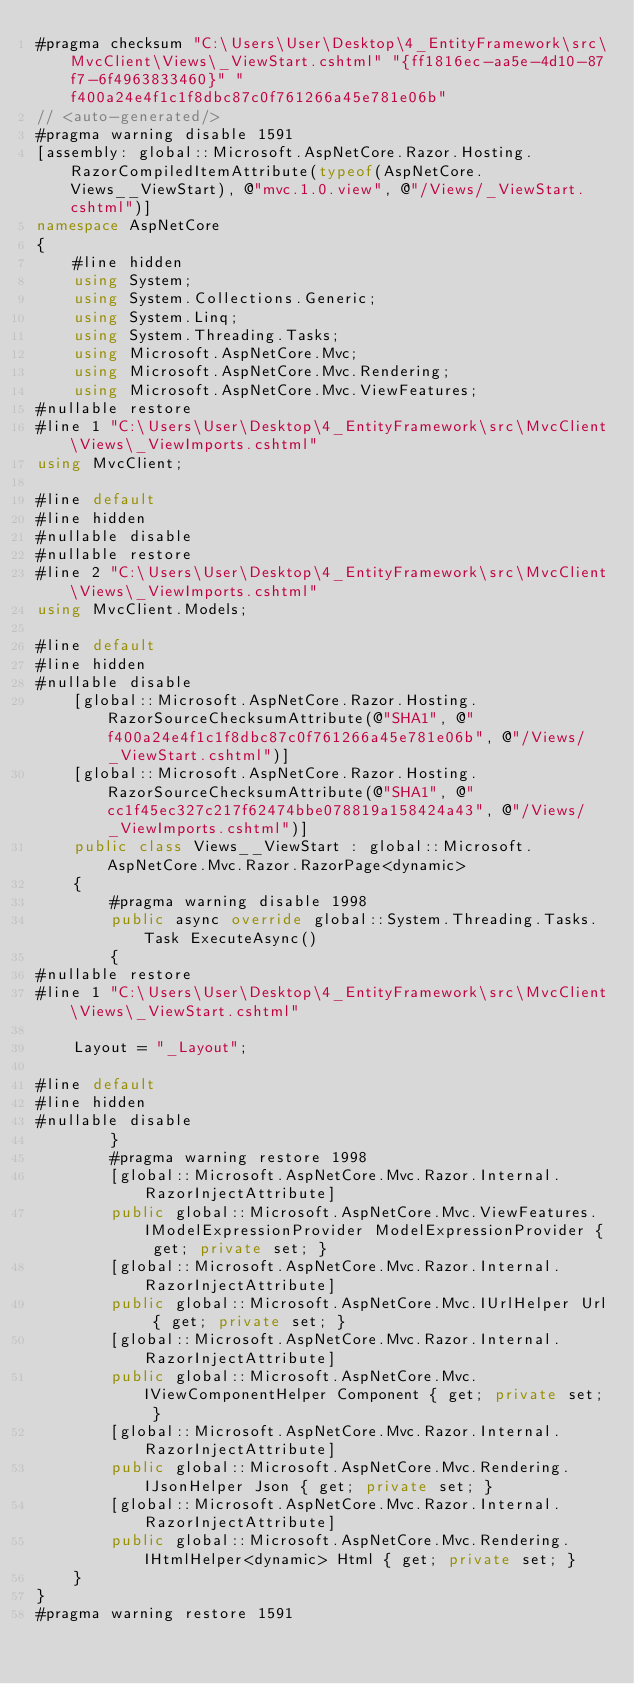<code> <loc_0><loc_0><loc_500><loc_500><_C#_>#pragma checksum "C:\Users\User\Desktop\4_EntityFramework\src\MvcClient\Views\_ViewStart.cshtml" "{ff1816ec-aa5e-4d10-87f7-6f4963833460}" "f400a24e4f1c1f8dbc87c0f761266a45e781e06b"
// <auto-generated/>
#pragma warning disable 1591
[assembly: global::Microsoft.AspNetCore.Razor.Hosting.RazorCompiledItemAttribute(typeof(AspNetCore.Views__ViewStart), @"mvc.1.0.view", @"/Views/_ViewStart.cshtml")]
namespace AspNetCore
{
    #line hidden
    using System;
    using System.Collections.Generic;
    using System.Linq;
    using System.Threading.Tasks;
    using Microsoft.AspNetCore.Mvc;
    using Microsoft.AspNetCore.Mvc.Rendering;
    using Microsoft.AspNetCore.Mvc.ViewFeatures;
#nullable restore
#line 1 "C:\Users\User\Desktop\4_EntityFramework\src\MvcClient\Views\_ViewImports.cshtml"
using MvcClient;

#line default
#line hidden
#nullable disable
#nullable restore
#line 2 "C:\Users\User\Desktop\4_EntityFramework\src\MvcClient\Views\_ViewImports.cshtml"
using MvcClient.Models;

#line default
#line hidden
#nullable disable
    [global::Microsoft.AspNetCore.Razor.Hosting.RazorSourceChecksumAttribute(@"SHA1", @"f400a24e4f1c1f8dbc87c0f761266a45e781e06b", @"/Views/_ViewStart.cshtml")]
    [global::Microsoft.AspNetCore.Razor.Hosting.RazorSourceChecksumAttribute(@"SHA1", @"cc1f45ec327c217f62474bbe078819a158424a43", @"/Views/_ViewImports.cshtml")]
    public class Views__ViewStart : global::Microsoft.AspNetCore.Mvc.Razor.RazorPage<dynamic>
    {
        #pragma warning disable 1998
        public async override global::System.Threading.Tasks.Task ExecuteAsync()
        {
#nullable restore
#line 1 "C:\Users\User\Desktop\4_EntityFramework\src\MvcClient\Views\_ViewStart.cshtml"
  
    Layout = "_Layout";

#line default
#line hidden
#nullable disable
        }
        #pragma warning restore 1998
        [global::Microsoft.AspNetCore.Mvc.Razor.Internal.RazorInjectAttribute]
        public global::Microsoft.AspNetCore.Mvc.ViewFeatures.IModelExpressionProvider ModelExpressionProvider { get; private set; }
        [global::Microsoft.AspNetCore.Mvc.Razor.Internal.RazorInjectAttribute]
        public global::Microsoft.AspNetCore.Mvc.IUrlHelper Url { get; private set; }
        [global::Microsoft.AspNetCore.Mvc.Razor.Internal.RazorInjectAttribute]
        public global::Microsoft.AspNetCore.Mvc.IViewComponentHelper Component { get; private set; }
        [global::Microsoft.AspNetCore.Mvc.Razor.Internal.RazorInjectAttribute]
        public global::Microsoft.AspNetCore.Mvc.Rendering.IJsonHelper Json { get; private set; }
        [global::Microsoft.AspNetCore.Mvc.Razor.Internal.RazorInjectAttribute]
        public global::Microsoft.AspNetCore.Mvc.Rendering.IHtmlHelper<dynamic> Html { get; private set; }
    }
}
#pragma warning restore 1591
</code> 